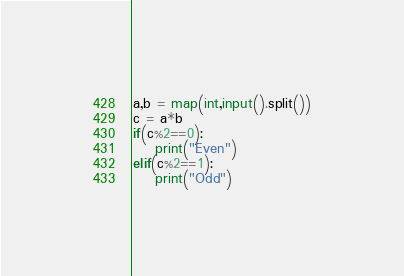<code> <loc_0><loc_0><loc_500><loc_500><_Python_>a,b = map(int,input().split())
c = a*b
if(c%2==0):
    print("Even")
elif(c%2==1):
    print("Odd")</code> 